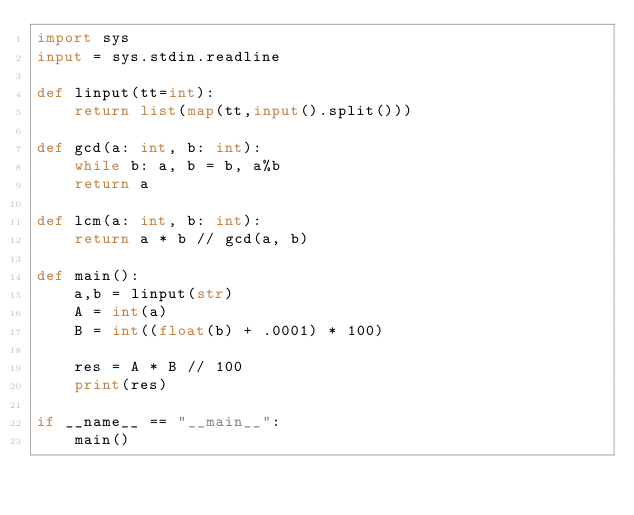Convert code to text. <code><loc_0><loc_0><loc_500><loc_500><_Python_>import sys
input = sys.stdin.readline

def linput(tt=int):
	return list(map(tt,input().split()))

def gcd(a: int, b: int):
	while b: a, b = b, a%b
	return a

def lcm(a: int, b: int):
	return a * b // gcd(a, b)

def main():
	a,b = linput(str)
	A = int(a)
	B = int((float(b) + .0001) * 100)
	
	res = A * B // 100
	print(res)

if __name__ == "__main__":
	main()
</code> 